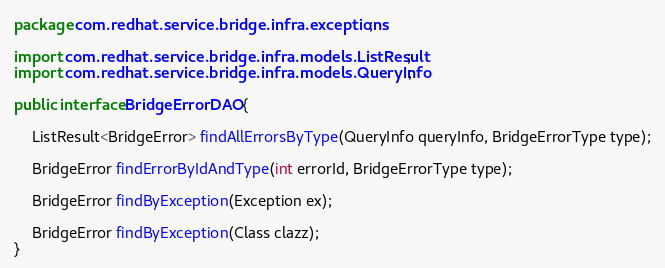Convert code to text. <code><loc_0><loc_0><loc_500><loc_500><_Java_>package com.redhat.service.bridge.infra.exceptions;

import com.redhat.service.bridge.infra.models.ListResult;
import com.redhat.service.bridge.infra.models.QueryInfo;

public interface BridgeErrorDAO {

    ListResult<BridgeError> findAllErrorsByType(QueryInfo queryInfo, BridgeErrorType type);

    BridgeError findErrorByIdAndType(int errorId, BridgeErrorType type);

    BridgeError findByException(Exception ex);

    BridgeError findByException(Class clazz);
}
</code> 